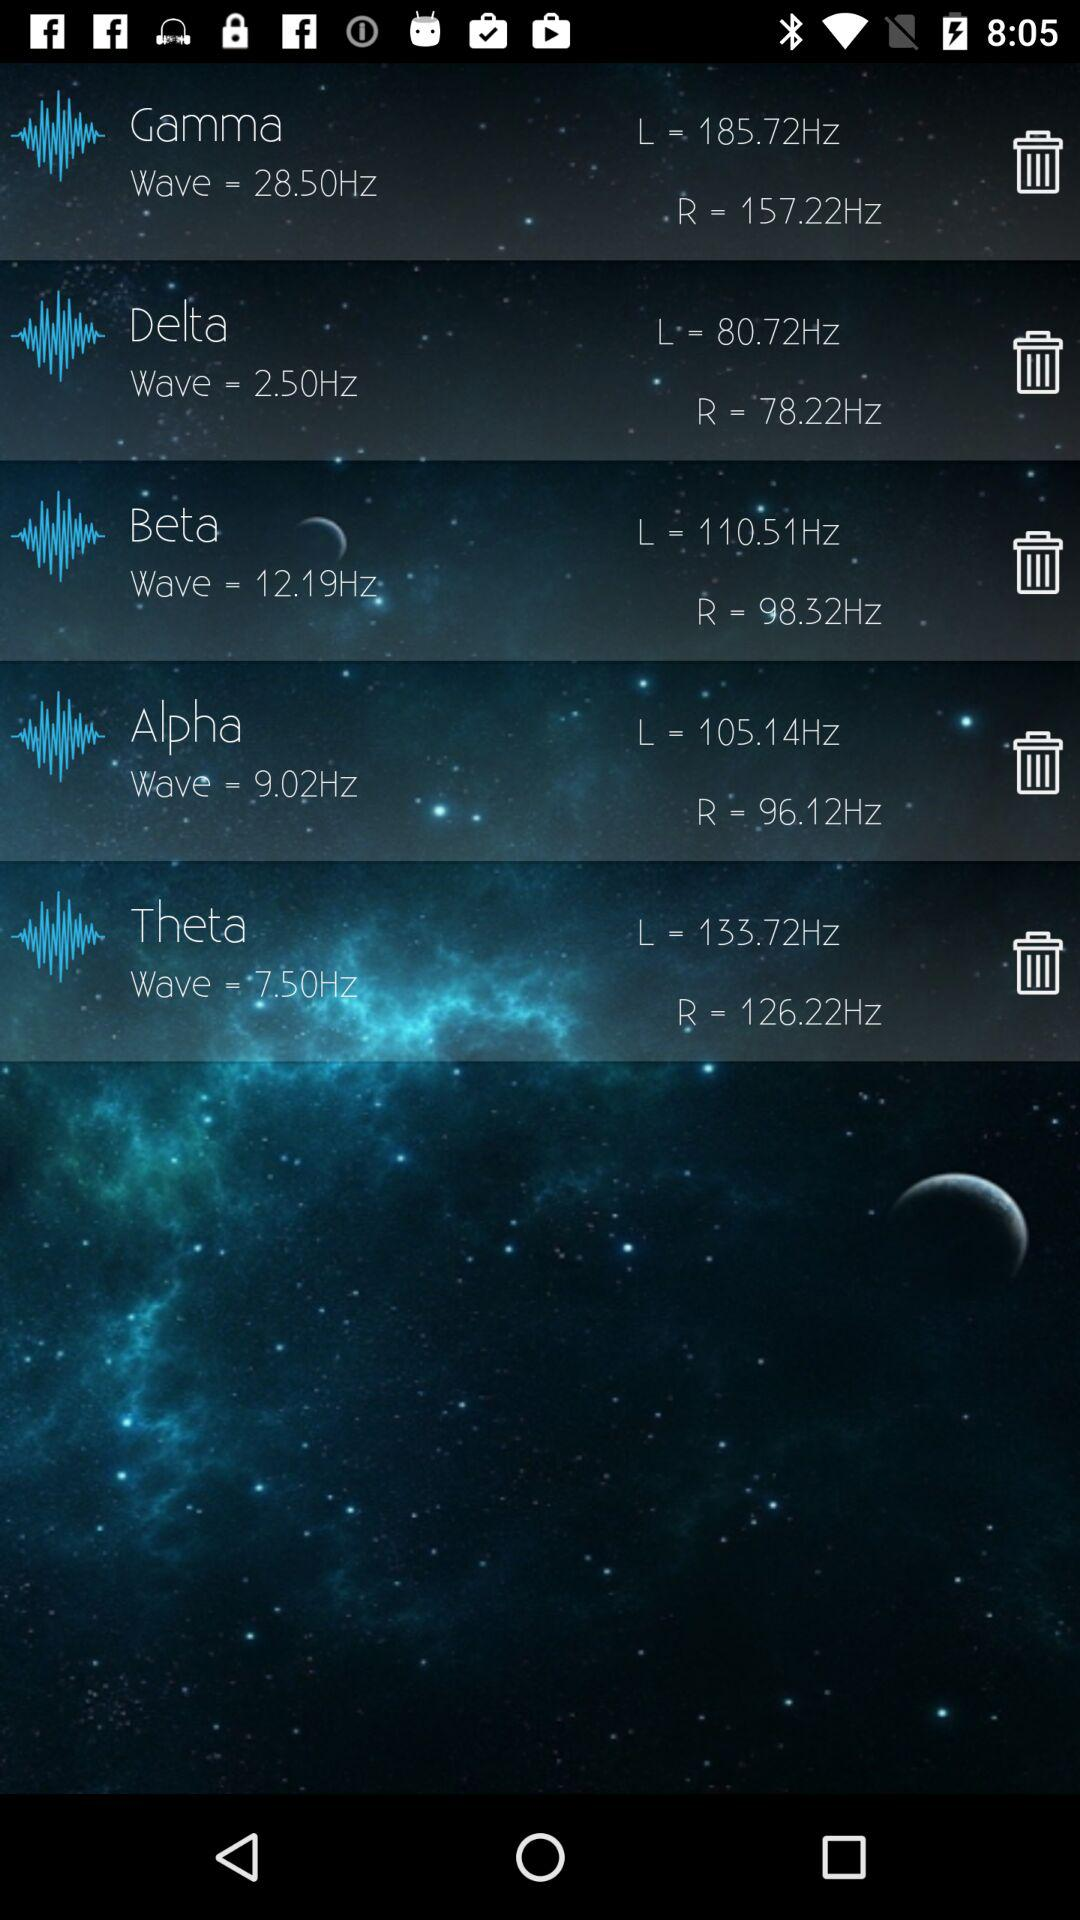What's the frequency of delta? The frequency of delta is 2.50 Hz. 